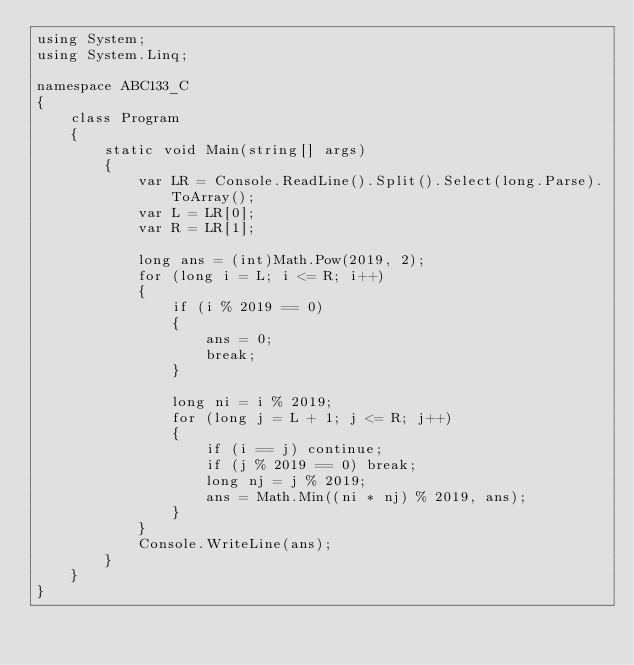Convert code to text. <code><loc_0><loc_0><loc_500><loc_500><_C#_>using System;
using System.Linq;

namespace ABC133_C
{
    class Program
    {
        static void Main(string[] args)
        {
            var LR = Console.ReadLine().Split().Select(long.Parse).ToArray();
            var L = LR[0];
            var R = LR[1];

            long ans = (int)Math.Pow(2019, 2);
            for (long i = L; i <= R; i++)
            {
                if (i % 2019 == 0)
                {
                    ans = 0;
                    break;
                }

                long ni = i % 2019;
                for (long j = L + 1; j <= R; j++)
                {
                    if (i == j) continue;
                    if (j % 2019 == 0) break;
                    long nj = j % 2019;
                    ans = Math.Min((ni * nj) % 2019, ans);
                }
            }
            Console.WriteLine(ans);
        }
    }
}
</code> 